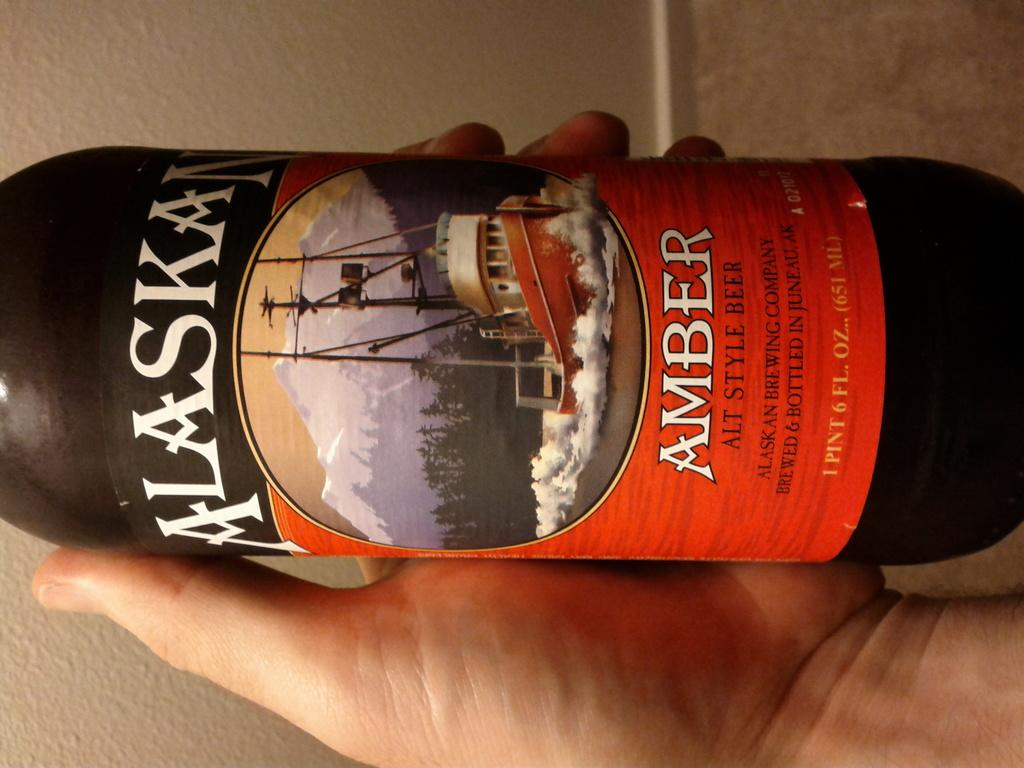<image>
Provide a brief description of the given image. man holding a beer bottle called amber alaska 